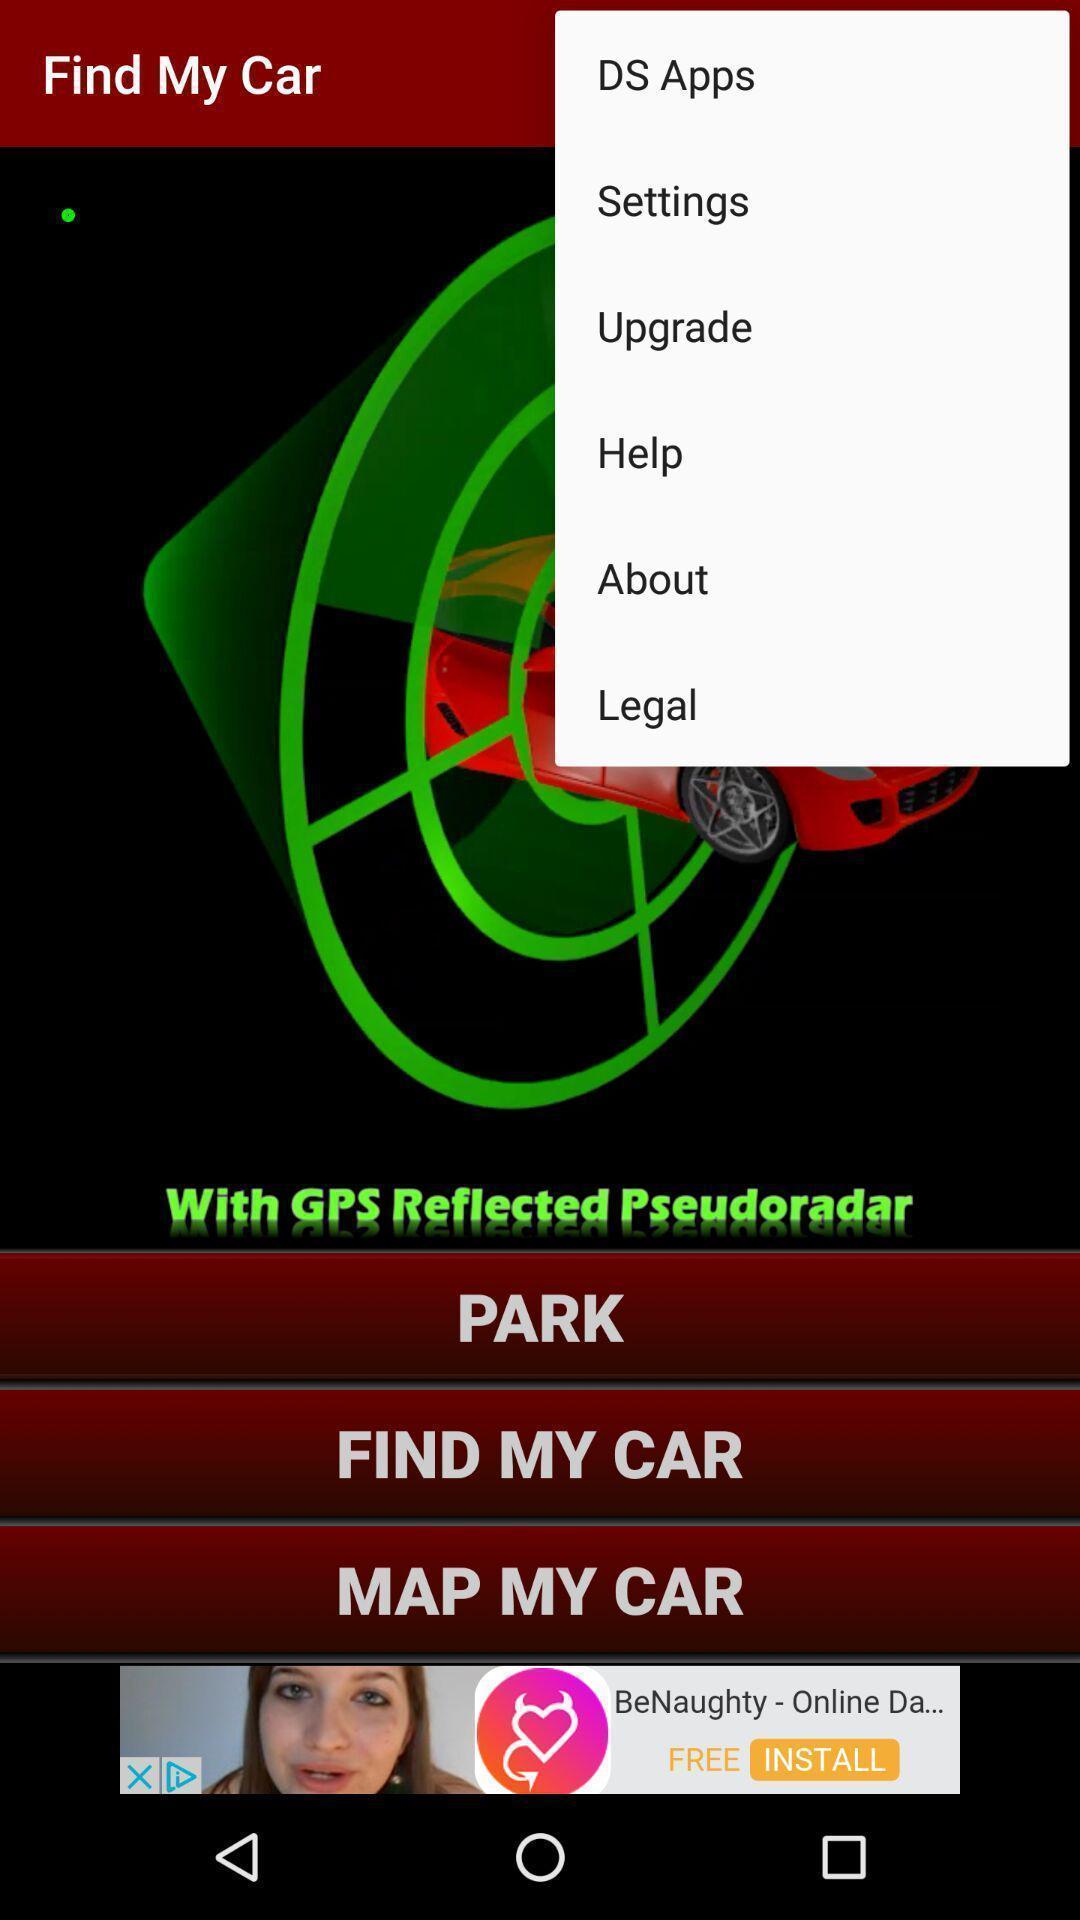Explain the elements present in this screenshot. Page showing the more options. 